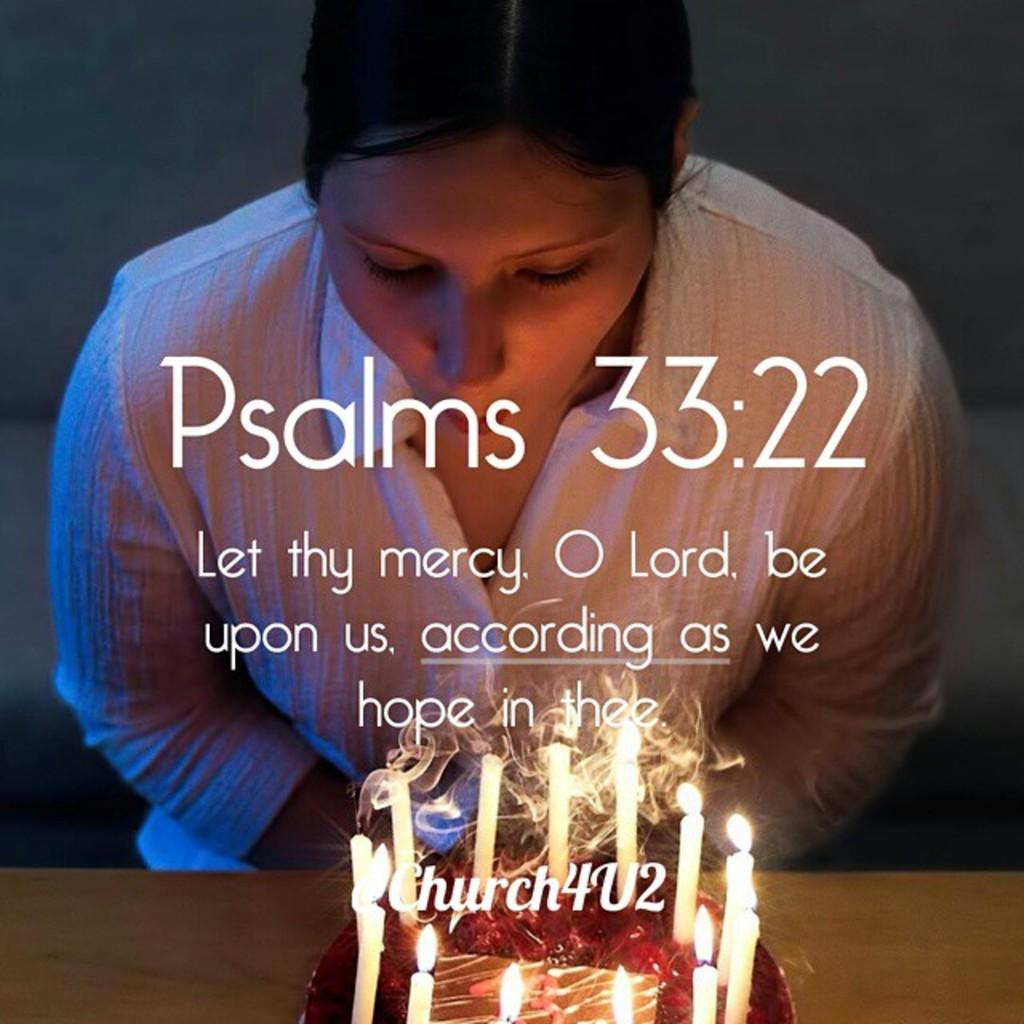Who is the main subject in the image? There is a woman in the image. What is the woman doing in the image? The woman is blowing candles. Where are the candles located? The candles are on a cake. Is there any text or design on the cake? Yes, there is writing on the cake. How many sheep are visible in the image? There are no sheep present in the image. Can you describe the cat sitting next to the woman in the image? There is no cat present in the image. 